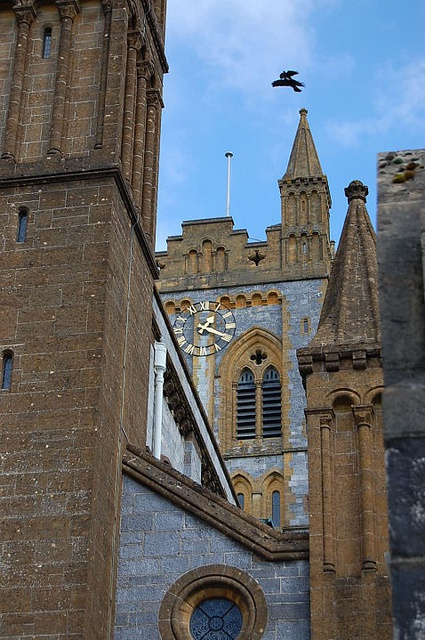Describe the objects in this image and their specific colors. I can see clock in black, gray, darkgray, ivory, and tan tones, bird in black, navy, gray, and blue tones, and bird in black, navy, gray, and blue tones in this image. 